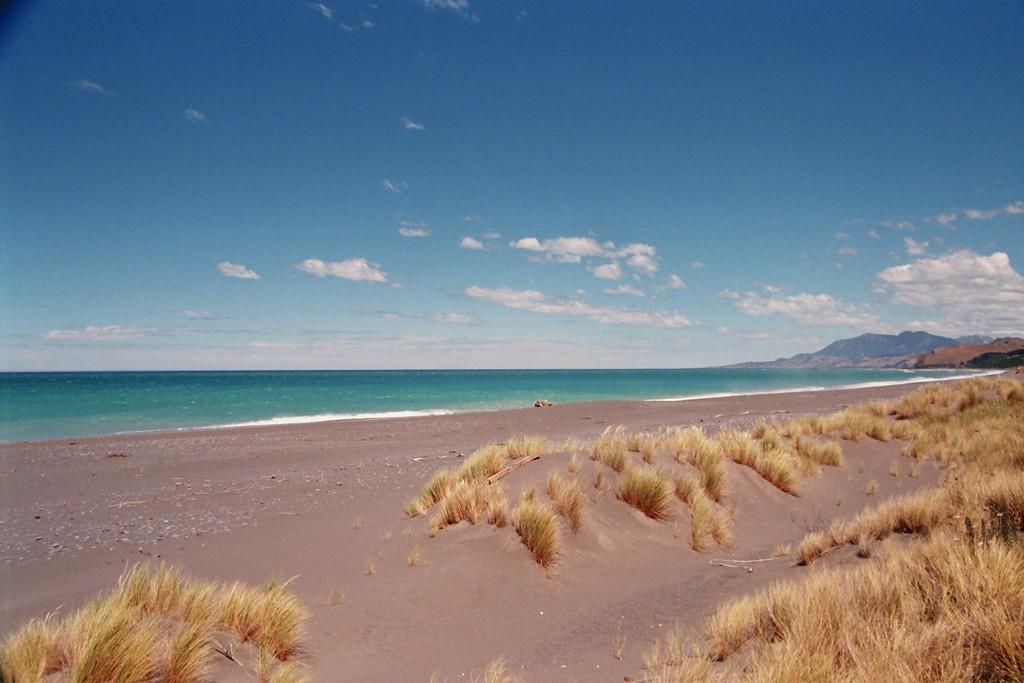What type of terrain is visible in the image? There is ground visible in the image, with brown grass on it. What can be seen in the distance in the image? There is water, mountains, and the sky visible in the background. Can you describe the color of the grass in the image? The grass is brown in the image. Is there any blood visible on the grass in the image? No, there is no blood visible on the grass in the image. Can you see a vase on the ground in the image? No, there is no vase present in the image. 